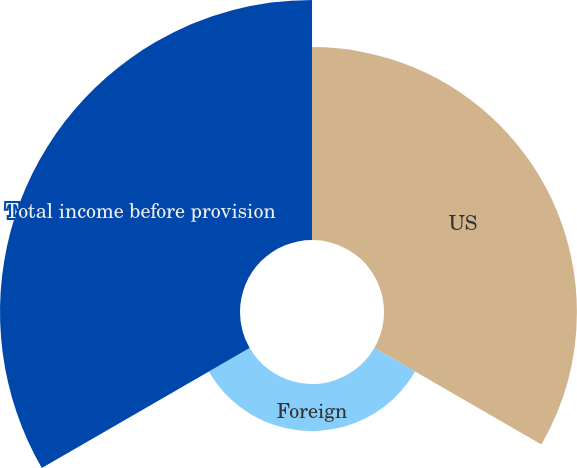Convert chart. <chart><loc_0><loc_0><loc_500><loc_500><pie_chart><fcel>US<fcel>Foreign<fcel>Total income before provision<nl><fcel>40.19%<fcel>9.81%<fcel>50.0%<nl></chart> 